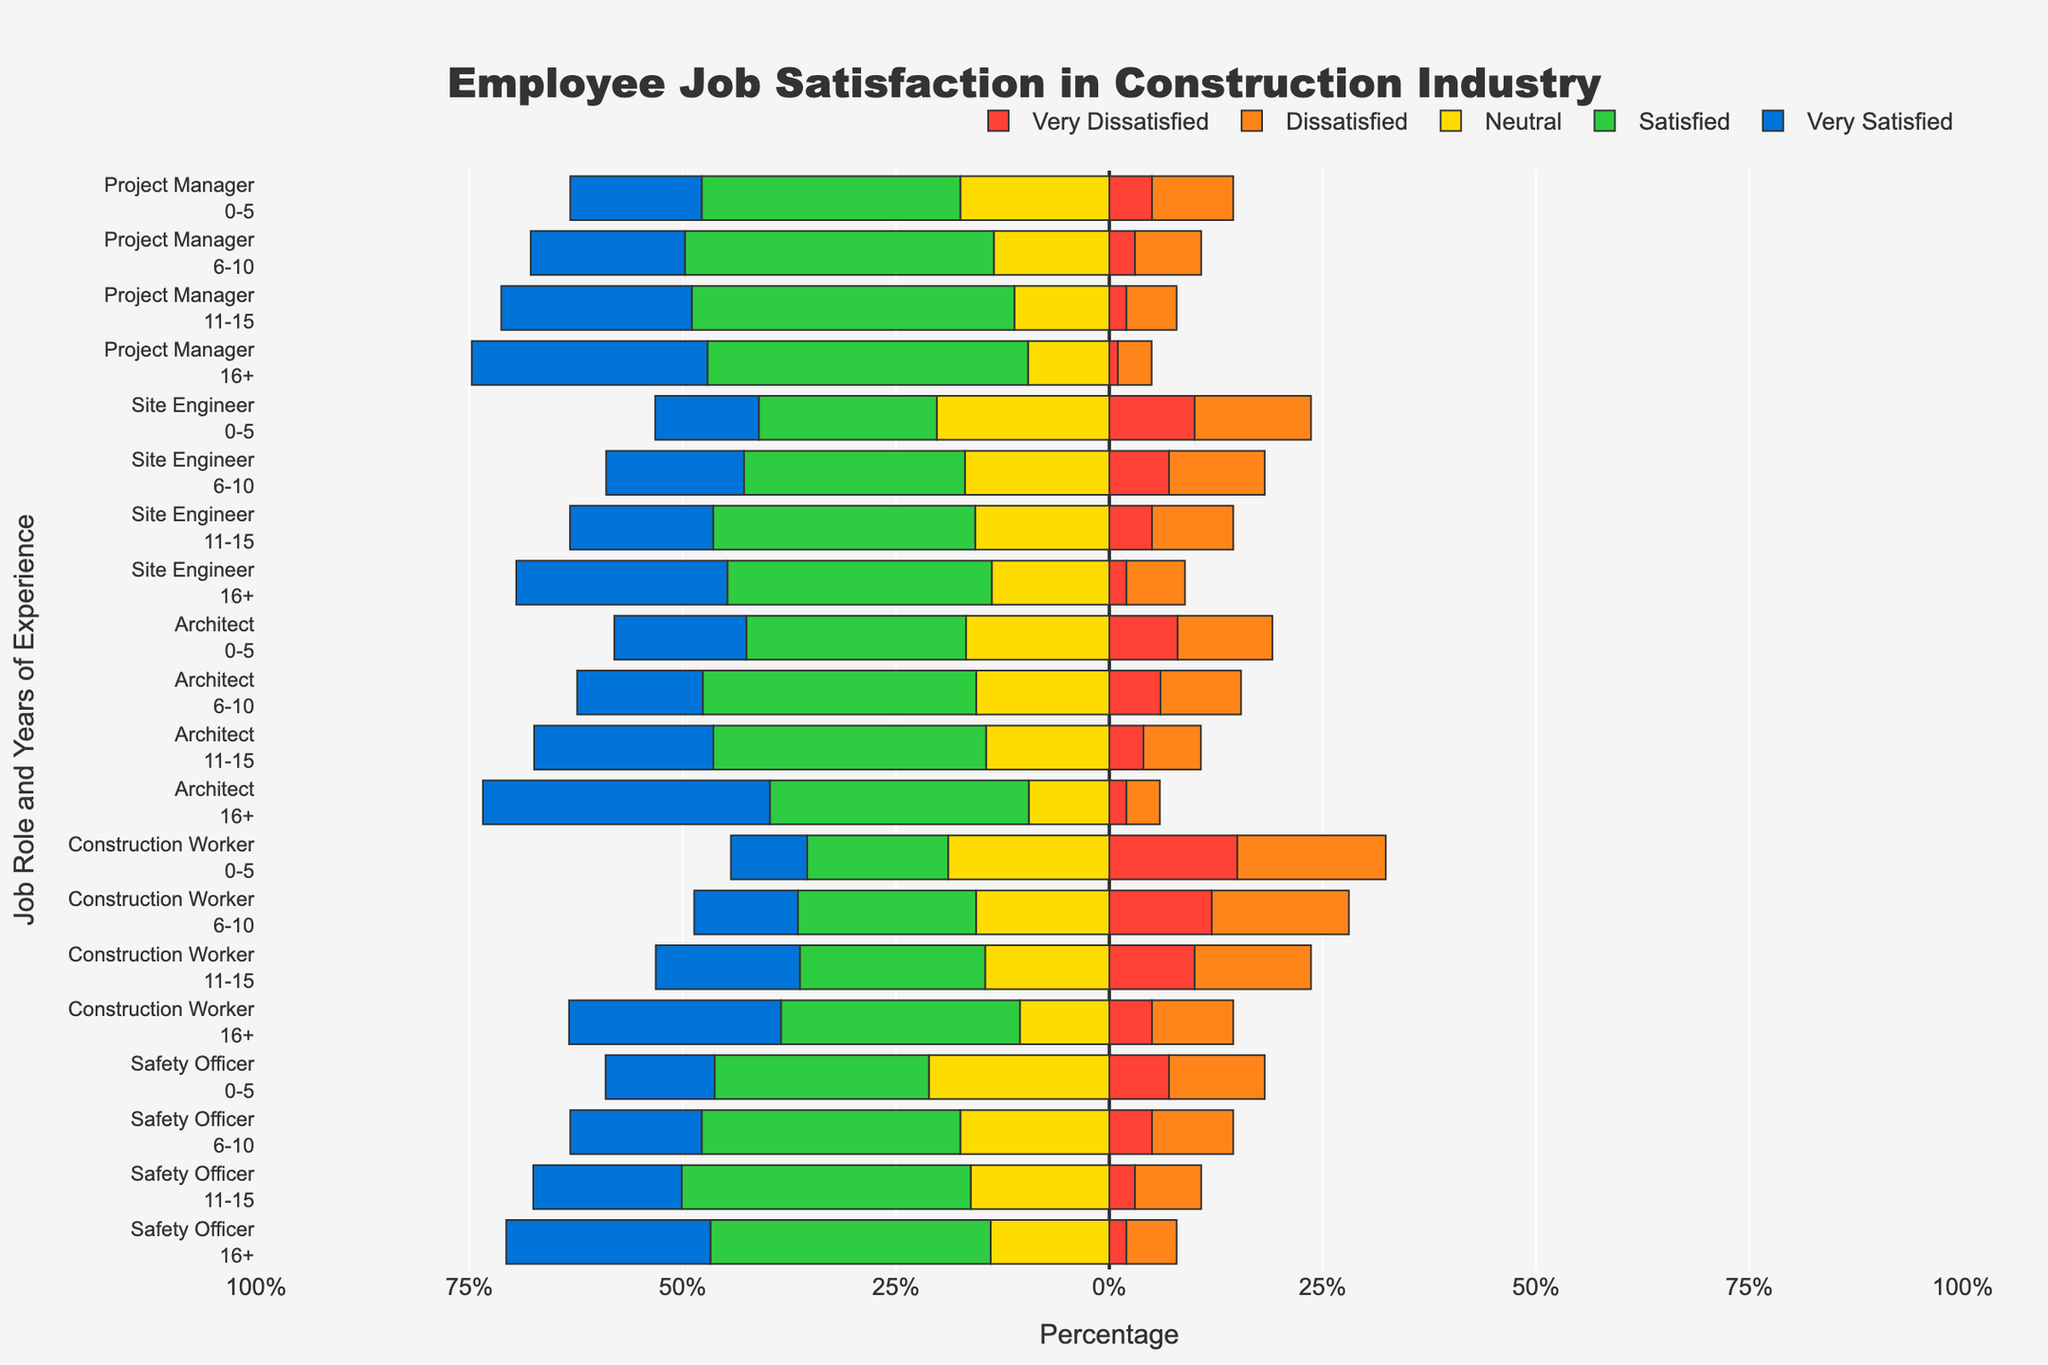Which job role with 16+ years of experience has the highest percentage of 'Very Satisfied' employees? To determine this, identify the 'Very Satisfied' category for the 16+ years of experience within each job role. The architect role has the highest percentage at 49%.
Answer: Architect How does the percentage of 'Dissatisfied' employees compare between Project Managers and Site Engineers with 6-10 years of experience? Look at the 'Dissatisfied' bar for both roles with 6-10 years of experience. Project Managers have 8%, while Site Engineers have 12%. Therefore, Site Engineers have a higher percentage.
Answer: Site Engineers have a higher percentage Which group has the highest combined percentage of 'Satisfied' and 'Very Satisfied' employees among all job roles and years of experience? Sum the 'Satisfied' and 'Very Satisfied' percentages across all job roles and years of experience. The Architect role with 16+ years has the highest combined total of 84% (35% + 49%).
Answer: Architect, 16+ years What is the total percentage of 'Neutral' employees for Safety Officers across all years of experience combined? Add the 'Neutral' percentages for Safety Officers across all years of experience: 25% (0-5) + 20% (6-10) + 18% (11-15) + 15% (16+). The sum is 78%.
Answer: 78% For which job role and years of experience is the percentage of 'Very Dissatisfied' employees the lowest? Identify the lowest 'Very Dissatisfied' percentage among all job roles and years of experience. Project Managers with 16+ years have the lowest percentage at 1%.
Answer: Project Manager, 16+ years Compare the percentage of 'Satisfied' employees between all 'Architect' and 'Construction Worker' groups. Which group shows higher satisfaction? Calculate the average 'Satisfied' percentage for Architects (35% + 42% + 40% + 35%)/4 = 38%, and Construction Workers (25% + 30% + 30% + 35%)/4 = 30%. Architects have a higher average.
Answer: Architects How does the 'Satisfied' percentage for Site Engineers with 11-15 years compare to that of Safety Officers with the same experience? Compare the 'Satisfied' percentages for Site Engineers (40%) and Safety Officers (43%) with 11-15 years of experience. Safety Officers have a higher percentage.
Answer: Safety Officers What is the visual trend for job satisfaction for Project Managers as years of experience increase? Observe the change in bar lengths for Project Managers as experience increases. 'Very Satisfied' and 'Satisfied' percentages increase, while 'Very Dissatisfied' and 'Dissatisfied' percentages decrease with more experience.
Answer: Increased satisfaction with more experience 